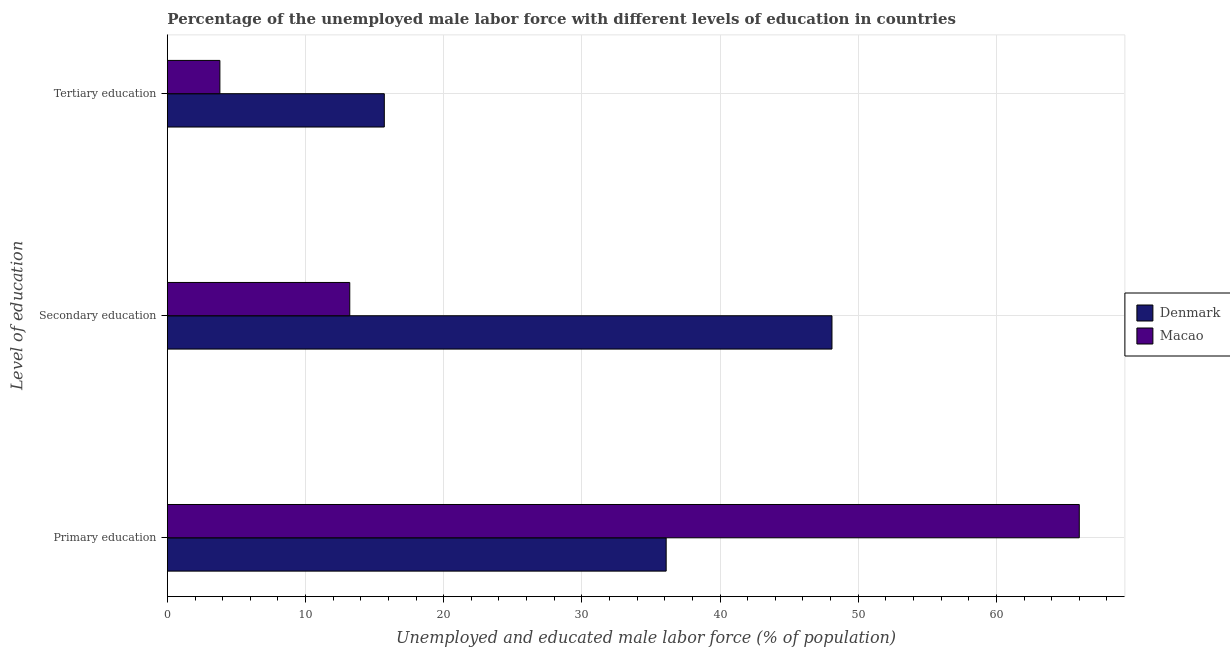Are the number of bars on each tick of the Y-axis equal?
Provide a short and direct response. Yes. How many bars are there on the 1st tick from the top?
Keep it short and to the point. 2. What is the percentage of male labor force who received tertiary education in Macao?
Keep it short and to the point. 3.8. Across all countries, what is the maximum percentage of male labor force who received secondary education?
Your answer should be very brief. 48.1. Across all countries, what is the minimum percentage of male labor force who received primary education?
Ensure brevity in your answer.  36.1. In which country was the percentage of male labor force who received tertiary education maximum?
Your response must be concise. Denmark. In which country was the percentage of male labor force who received secondary education minimum?
Your answer should be compact. Macao. What is the total percentage of male labor force who received tertiary education in the graph?
Give a very brief answer. 19.5. What is the difference between the percentage of male labor force who received primary education in Denmark and that in Macao?
Give a very brief answer. -29.9. What is the difference between the percentage of male labor force who received tertiary education in Macao and the percentage of male labor force who received secondary education in Denmark?
Offer a very short reply. -44.3. What is the average percentage of male labor force who received primary education per country?
Keep it short and to the point. 51.05. What is the difference between the percentage of male labor force who received primary education and percentage of male labor force who received tertiary education in Macao?
Your answer should be compact. 62.2. In how many countries, is the percentage of male labor force who received secondary education greater than 16 %?
Provide a succinct answer. 1. What is the ratio of the percentage of male labor force who received secondary education in Macao to that in Denmark?
Provide a short and direct response. 0.27. Is the difference between the percentage of male labor force who received primary education in Denmark and Macao greater than the difference between the percentage of male labor force who received tertiary education in Denmark and Macao?
Provide a succinct answer. No. What is the difference between the highest and the second highest percentage of male labor force who received tertiary education?
Your answer should be compact. 11.9. What is the difference between the highest and the lowest percentage of male labor force who received secondary education?
Ensure brevity in your answer.  34.9. In how many countries, is the percentage of male labor force who received tertiary education greater than the average percentage of male labor force who received tertiary education taken over all countries?
Your answer should be compact. 1. What does the 1st bar from the top in Primary education represents?
Your answer should be compact. Macao. Is it the case that in every country, the sum of the percentage of male labor force who received primary education and percentage of male labor force who received secondary education is greater than the percentage of male labor force who received tertiary education?
Provide a short and direct response. Yes. Are all the bars in the graph horizontal?
Give a very brief answer. Yes. Does the graph contain any zero values?
Offer a very short reply. No. Where does the legend appear in the graph?
Your answer should be very brief. Center right. How many legend labels are there?
Your response must be concise. 2. What is the title of the graph?
Ensure brevity in your answer.  Percentage of the unemployed male labor force with different levels of education in countries. What is the label or title of the X-axis?
Your answer should be compact. Unemployed and educated male labor force (% of population). What is the label or title of the Y-axis?
Make the answer very short. Level of education. What is the Unemployed and educated male labor force (% of population) in Denmark in Primary education?
Your response must be concise. 36.1. What is the Unemployed and educated male labor force (% of population) of Macao in Primary education?
Your answer should be compact. 66. What is the Unemployed and educated male labor force (% of population) of Denmark in Secondary education?
Offer a terse response. 48.1. What is the Unemployed and educated male labor force (% of population) of Macao in Secondary education?
Provide a short and direct response. 13.2. What is the Unemployed and educated male labor force (% of population) in Denmark in Tertiary education?
Offer a terse response. 15.7. What is the Unemployed and educated male labor force (% of population) in Macao in Tertiary education?
Provide a short and direct response. 3.8. Across all Level of education, what is the maximum Unemployed and educated male labor force (% of population) in Denmark?
Offer a terse response. 48.1. Across all Level of education, what is the minimum Unemployed and educated male labor force (% of population) in Denmark?
Keep it short and to the point. 15.7. Across all Level of education, what is the minimum Unemployed and educated male labor force (% of population) of Macao?
Provide a succinct answer. 3.8. What is the total Unemployed and educated male labor force (% of population) of Denmark in the graph?
Offer a terse response. 99.9. What is the total Unemployed and educated male labor force (% of population) in Macao in the graph?
Your answer should be very brief. 83. What is the difference between the Unemployed and educated male labor force (% of population) of Macao in Primary education and that in Secondary education?
Provide a succinct answer. 52.8. What is the difference between the Unemployed and educated male labor force (% of population) in Denmark in Primary education and that in Tertiary education?
Your response must be concise. 20.4. What is the difference between the Unemployed and educated male labor force (% of population) in Macao in Primary education and that in Tertiary education?
Offer a very short reply. 62.2. What is the difference between the Unemployed and educated male labor force (% of population) of Denmark in Secondary education and that in Tertiary education?
Provide a short and direct response. 32.4. What is the difference between the Unemployed and educated male labor force (% of population) of Macao in Secondary education and that in Tertiary education?
Your response must be concise. 9.4. What is the difference between the Unemployed and educated male labor force (% of population) of Denmark in Primary education and the Unemployed and educated male labor force (% of population) of Macao in Secondary education?
Your answer should be very brief. 22.9. What is the difference between the Unemployed and educated male labor force (% of population) in Denmark in Primary education and the Unemployed and educated male labor force (% of population) in Macao in Tertiary education?
Offer a very short reply. 32.3. What is the difference between the Unemployed and educated male labor force (% of population) in Denmark in Secondary education and the Unemployed and educated male labor force (% of population) in Macao in Tertiary education?
Ensure brevity in your answer.  44.3. What is the average Unemployed and educated male labor force (% of population) in Denmark per Level of education?
Your answer should be very brief. 33.3. What is the average Unemployed and educated male labor force (% of population) in Macao per Level of education?
Keep it short and to the point. 27.67. What is the difference between the Unemployed and educated male labor force (% of population) in Denmark and Unemployed and educated male labor force (% of population) in Macao in Primary education?
Ensure brevity in your answer.  -29.9. What is the difference between the Unemployed and educated male labor force (% of population) of Denmark and Unemployed and educated male labor force (% of population) of Macao in Secondary education?
Keep it short and to the point. 34.9. What is the ratio of the Unemployed and educated male labor force (% of population) in Denmark in Primary education to that in Secondary education?
Your response must be concise. 0.75. What is the ratio of the Unemployed and educated male labor force (% of population) in Denmark in Primary education to that in Tertiary education?
Your response must be concise. 2.3. What is the ratio of the Unemployed and educated male labor force (% of population) of Macao in Primary education to that in Tertiary education?
Offer a very short reply. 17.37. What is the ratio of the Unemployed and educated male labor force (% of population) in Denmark in Secondary education to that in Tertiary education?
Your answer should be very brief. 3.06. What is the ratio of the Unemployed and educated male labor force (% of population) in Macao in Secondary education to that in Tertiary education?
Ensure brevity in your answer.  3.47. What is the difference between the highest and the second highest Unemployed and educated male labor force (% of population) in Macao?
Offer a terse response. 52.8. What is the difference between the highest and the lowest Unemployed and educated male labor force (% of population) in Denmark?
Your answer should be very brief. 32.4. What is the difference between the highest and the lowest Unemployed and educated male labor force (% of population) of Macao?
Ensure brevity in your answer.  62.2. 